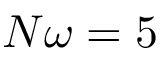<formula> <loc_0><loc_0><loc_500><loc_500>N \omega = 5</formula> 